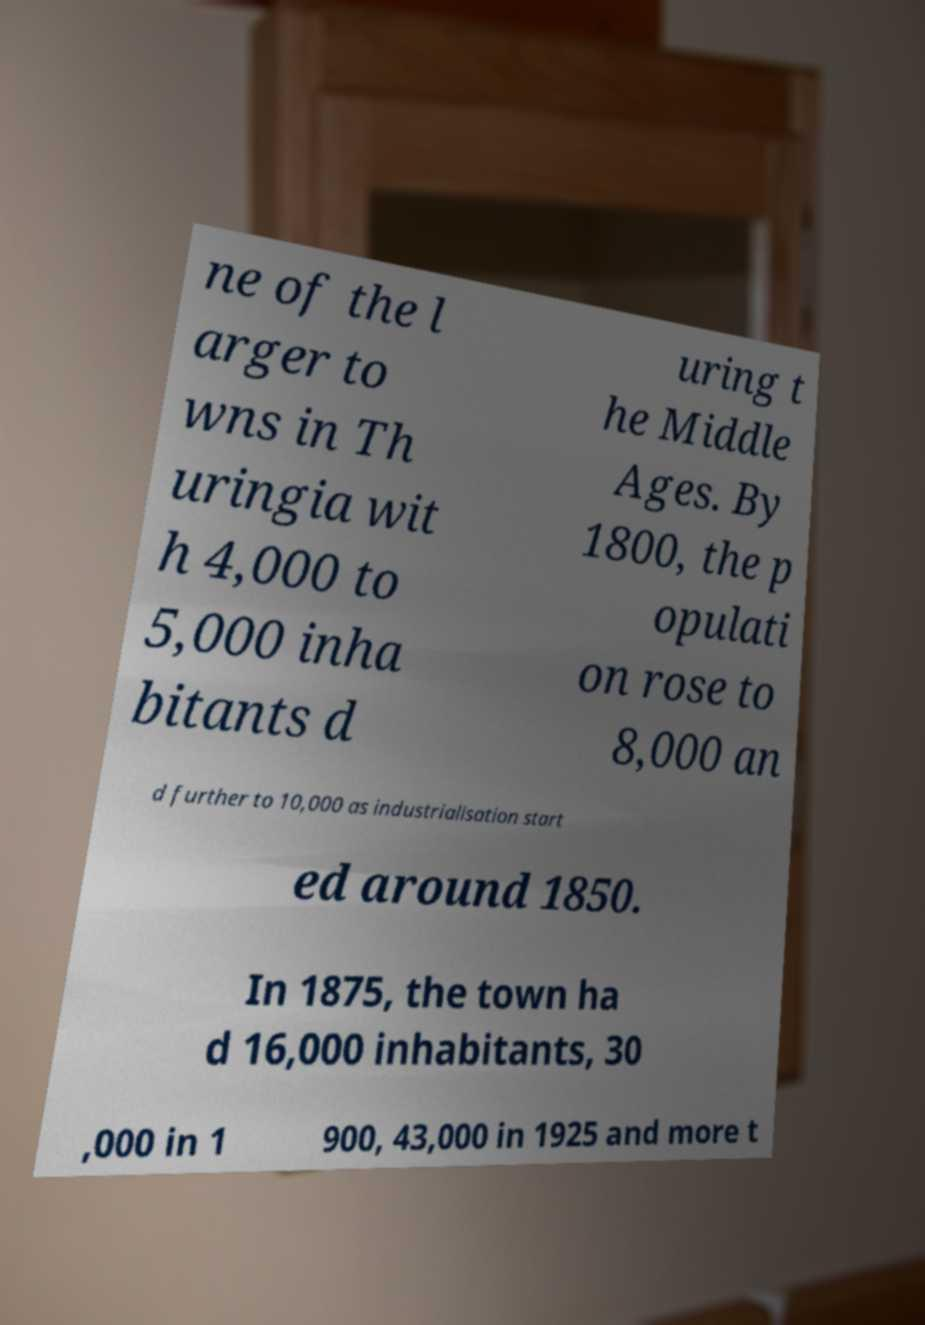Please identify and transcribe the text found in this image. ne of the l arger to wns in Th uringia wit h 4,000 to 5,000 inha bitants d uring t he Middle Ages. By 1800, the p opulati on rose to 8,000 an d further to 10,000 as industrialisation start ed around 1850. In 1875, the town ha d 16,000 inhabitants, 30 ,000 in 1 900, 43,000 in 1925 and more t 